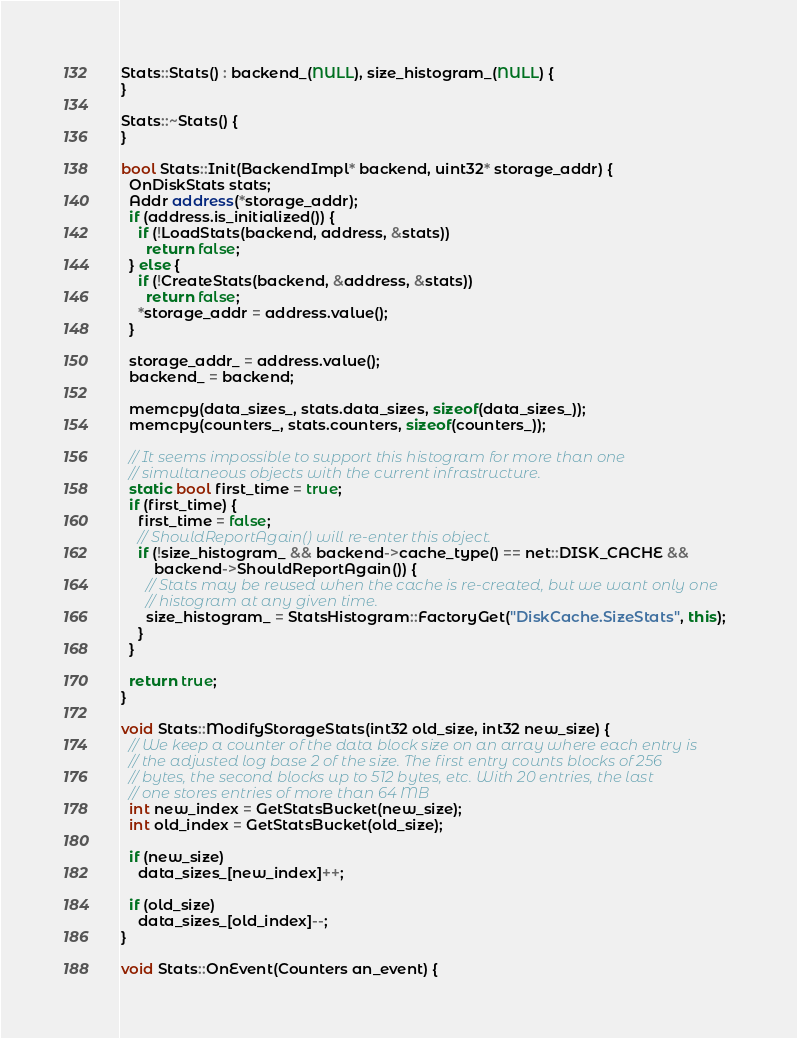<code> <loc_0><loc_0><loc_500><loc_500><_C++_>
Stats::Stats() : backend_(NULL), size_histogram_(NULL) {
}

Stats::~Stats() {
}

bool Stats::Init(BackendImpl* backend, uint32* storage_addr) {
  OnDiskStats stats;
  Addr address(*storage_addr);
  if (address.is_initialized()) {
    if (!LoadStats(backend, address, &stats))
      return false;
  } else {
    if (!CreateStats(backend, &address, &stats))
      return false;
    *storage_addr = address.value();
  }

  storage_addr_ = address.value();
  backend_ = backend;

  memcpy(data_sizes_, stats.data_sizes, sizeof(data_sizes_));
  memcpy(counters_, stats.counters, sizeof(counters_));

  // It seems impossible to support this histogram for more than one
  // simultaneous objects with the current infrastructure.
  static bool first_time = true;
  if (first_time) {
    first_time = false;
    // ShouldReportAgain() will re-enter this object.
    if (!size_histogram_ && backend->cache_type() == net::DISK_CACHE &&
        backend->ShouldReportAgain()) {
      // Stats may be reused when the cache is re-created, but we want only one
      // histogram at any given time.
      size_histogram_ = StatsHistogram::FactoryGet("DiskCache.SizeStats", this);
    }
  }

  return true;
}

void Stats::ModifyStorageStats(int32 old_size, int32 new_size) {
  // We keep a counter of the data block size on an array where each entry is
  // the adjusted log base 2 of the size. The first entry counts blocks of 256
  // bytes, the second blocks up to 512 bytes, etc. With 20 entries, the last
  // one stores entries of more than 64 MB
  int new_index = GetStatsBucket(new_size);
  int old_index = GetStatsBucket(old_size);

  if (new_size)
    data_sizes_[new_index]++;

  if (old_size)
    data_sizes_[old_index]--;
}

void Stats::OnEvent(Counters an_event) {</code> 